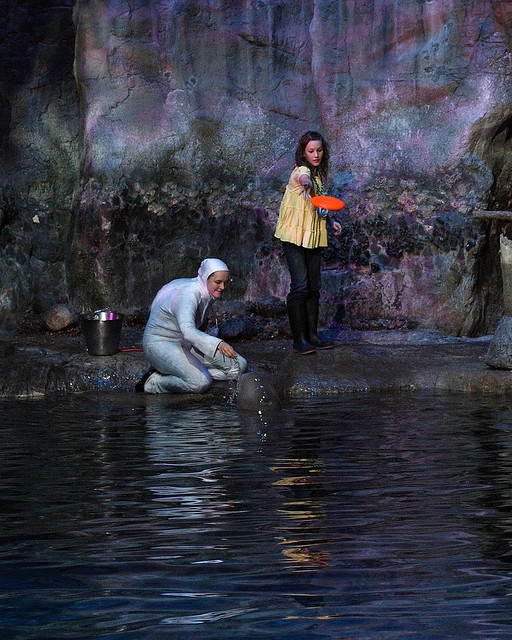Describe the objects in this image and their specific colors. I can see people in black, darkgray, and gray tones, people in black and tan tones, and frisbee in black, red, salmon, and brown tones in this image. 